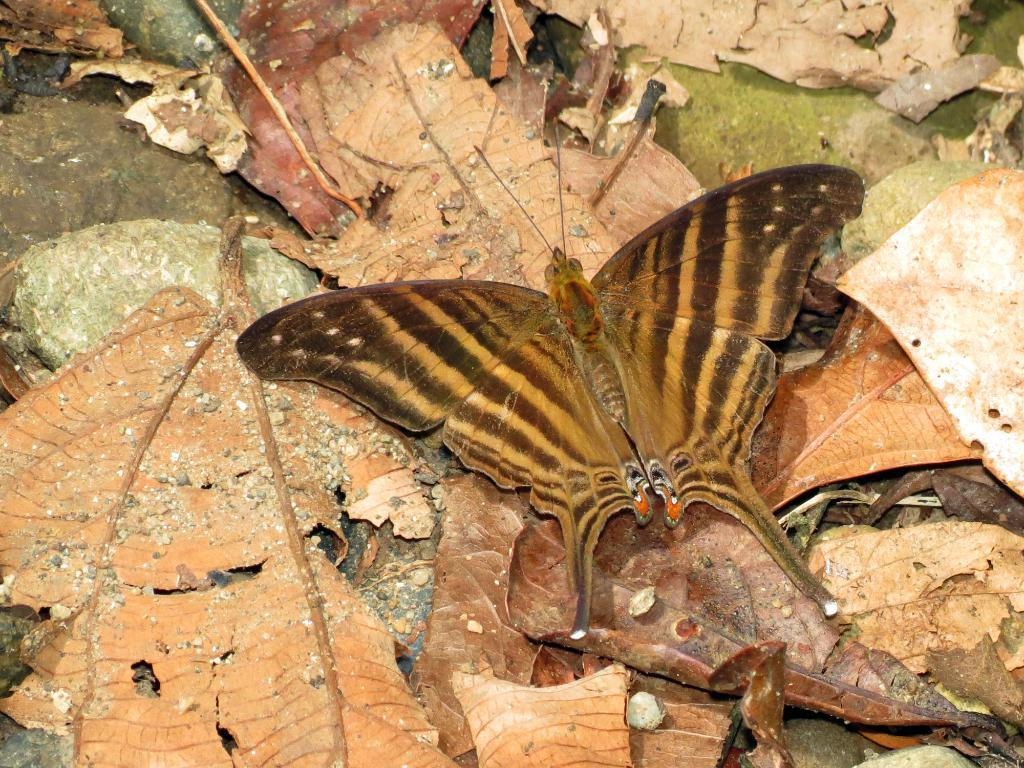What is the main subject of the image? The main subject of the image is a butterfly. Can you describe the colors of the butterfly? The butterfly has brown and black colors. Where is the butterfly located in the image? The butterfly is on leaves. What is the color of the leaves? The leaves are in brown color. Where are the leaves located? The leaves are on the road. What type of butter does the butterfly prefer in the image? There is no butter or any indication of the butterfly's preference for butter in the image. What type of business is being conducted on the road in the image? There is no business activity depicted in the image; it primarily features a butterfly on leaves on the road. 